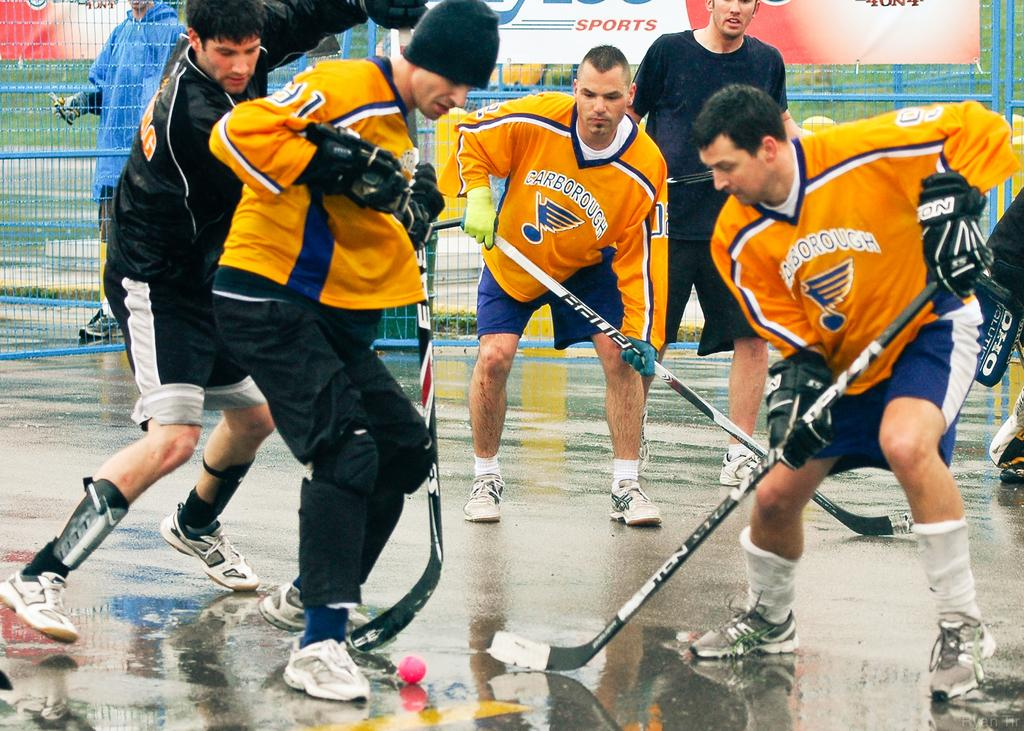<image>
Summarize the visual content of the image. Three hockey players wearing yellow jerseys that say Scarborough 